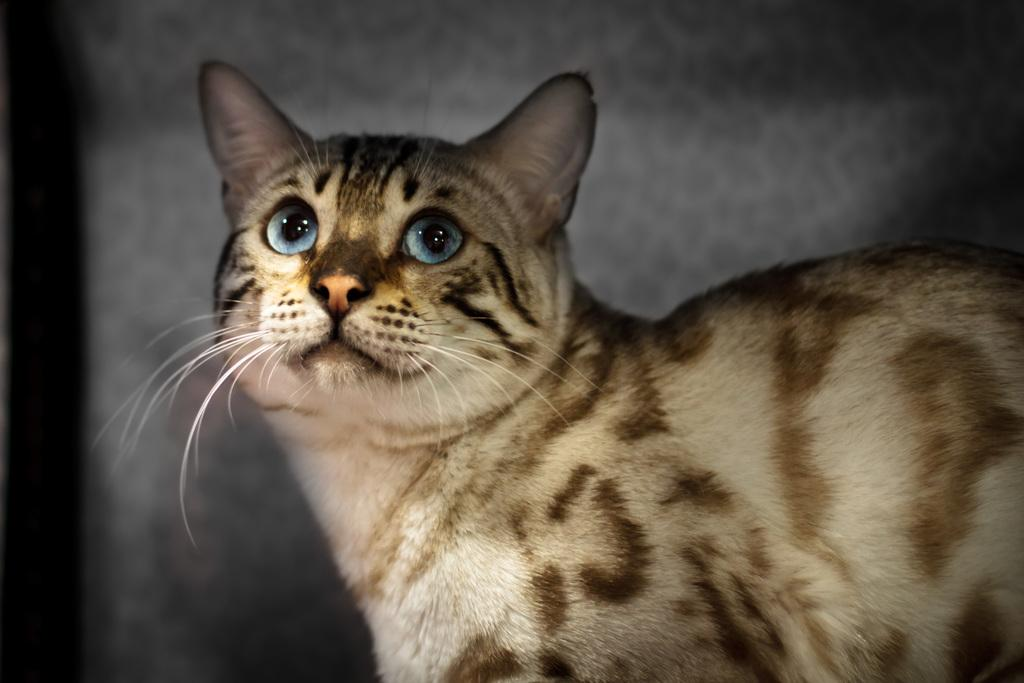What is the main subject in the foreground of the image? There is a cat in the foreground of the image. What is the cat doing in the image? The cat is looking at something. Can you describe the background of the image? The background of the image is blurred. How many birds can be seen falling from the sky in the image? There are no birds or falling motion visible in the image. 